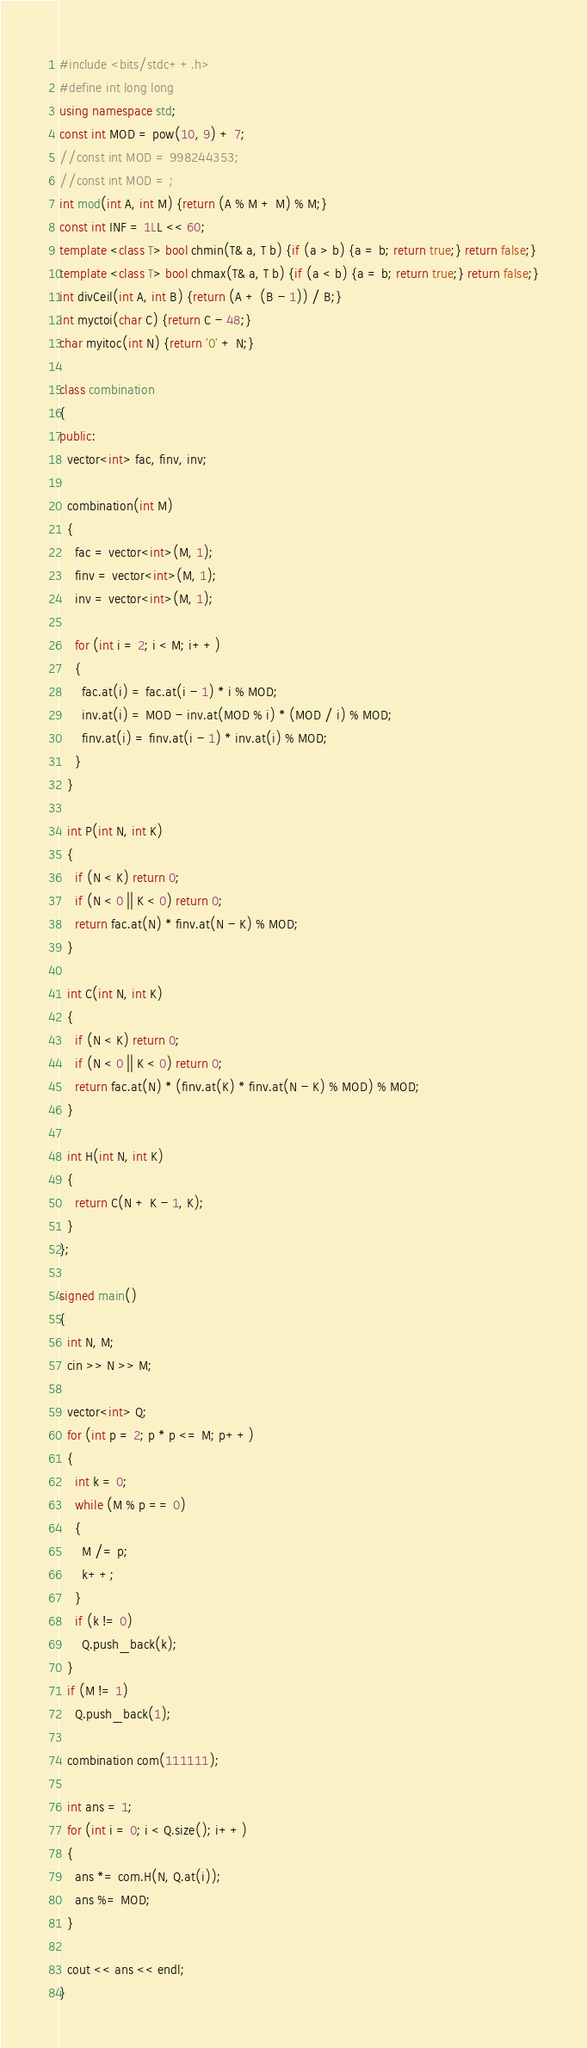Convert code to text. <code><loc_0><loc_0><loc_500><loc_500><_C++_>#include <bits/stdc++.h>
#define int long long
using namespace std;
const int MOD = pow(10, 9) + 7;
//const int MOD = 998244353;
//const int MOD = ;
int mod(int A, int M) {return (A % M + M) % M;}
const int INF = 1LL << 60;
template <class T> bool chmin(T& a, T b) {if (a > b) {a = b; return true;} return false;}
template <class T> bool chmax(T& a, T b) {if (a < b) {a = b; return true;} return false;}
int divCeil(int A, int B) {return (A + (B - 1)) / B;}
int myctoi(char C) {return C - 48;}
char myitoc(int N) {return '0' + N;}

class combination
{
public:
  vector<int> fac, finv, inv;

  combination(int M)
  {
    fac = vector<int>(M, 1);
    finv = vector<int>(M, 1);
    inv = vector<int>(M, 1);

    for (int i = 2; i < M; i++)
    {
      fac.at(i) = fac.at(i - 1) * i % MOD;
      inv.at(i) = MOD - inv.at(MOD % i) * (MOD / i) % MOD;
      finv.at(i) = finv.at(i - 1) * inv.at(i) % MOD;
    }
  }

  int P(int N, int K)
  {
    if (N < K) return 0;
    if (N < 0 || K < 0) return 0;
    return fac.at(N) * finv.at(N - K) % MOD;
  }

  int C(int N, int K)
  {
    if (N < K) return 0;
    if (N < 0 || K < 0) return 0;
    return fac.at(N) * (finv.at(K) * finv.at(N - K) % MOD) % MOD;
  }

  int H(int N, int K)
  {
    return C(N + K - 1, K);
  }
};

signed main()
{
  int N, M;
  cin >> N >> M;

  vector<int> Q;
  for (int p = 2; p * p <= M; p++)
  {
    int k = 0;
    while (M % p == 0)
    {
      M /= p;
      k++;
    }
    if (k != 0)
      Q.push_back(k);
  }
  if (M != 1)
    Q.push_back(1);

  combination com(111111);

  int ans = 1;
  for (int i = 0; i < Q.size(); i++)
  {
    ans *= com.H(N, Q.at(i));
    ans %= MOD;
  }

  cout << ans << endl;
}</code> 